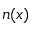<formula> <loc_0><loc_0><loc_500><loc_500>n ( x )</formula> 